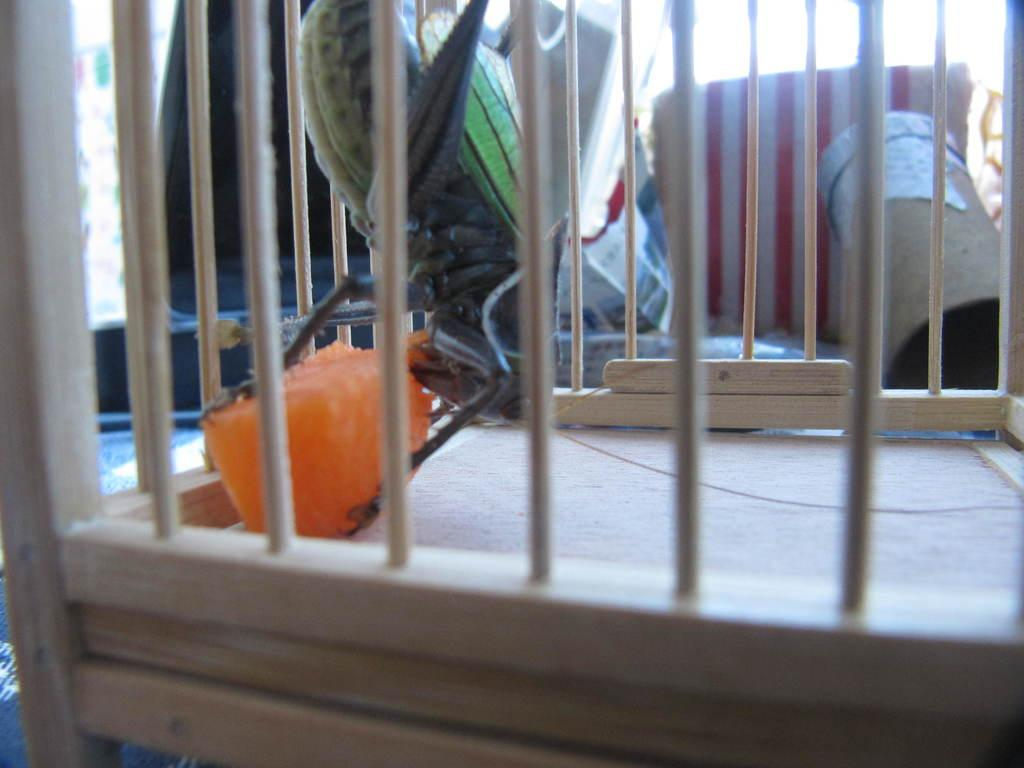What is present in the image that contains an insect? There is a cage in the image that contains an insect. What is inside the cage with the insect? There is a food item inside the cage. What can be seen in the background of the image? There are boxes and clothes in the background of the image. What type of egg is being used as a toy in the image? There is no egg or toy present in the image. What is the insect eating for breakfast in the image? The image does not show the insect eating anything, nor does it depict a breakfast scene. 